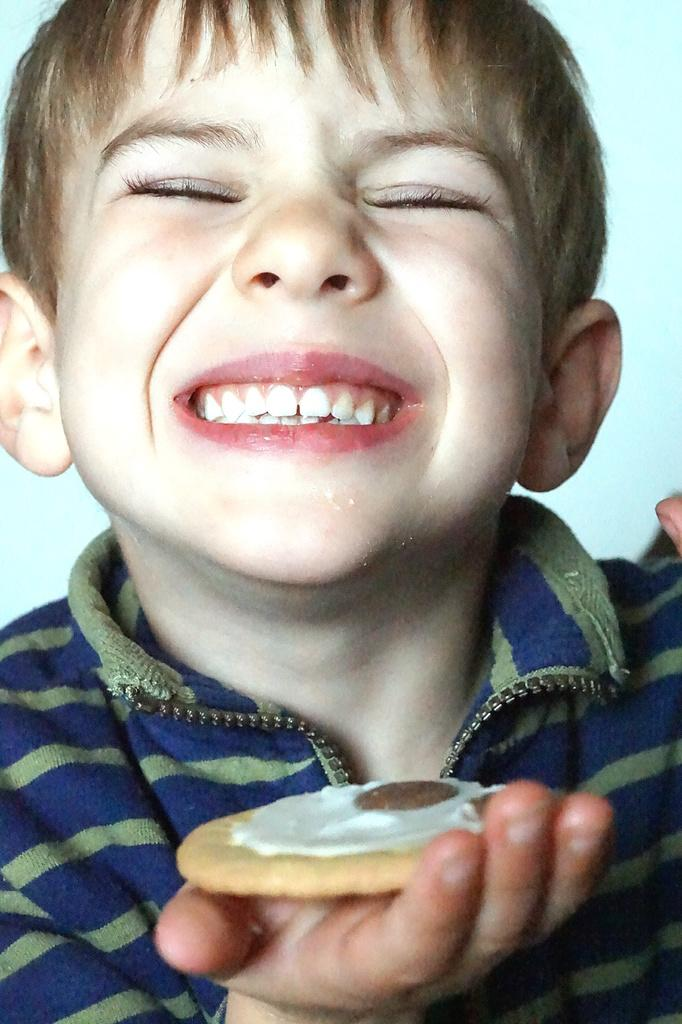Who is in the image? There is a boy in the image. What is the boy doing? The boy is smiling. What is the boy holding in the image? The boy is holding a biscuit. What can be seen in the background of the image? There is a wall in the background of the image. What type of alarm can be heard going off in the image? There is no alarm present in the image, and therefore no sound can be heard. 